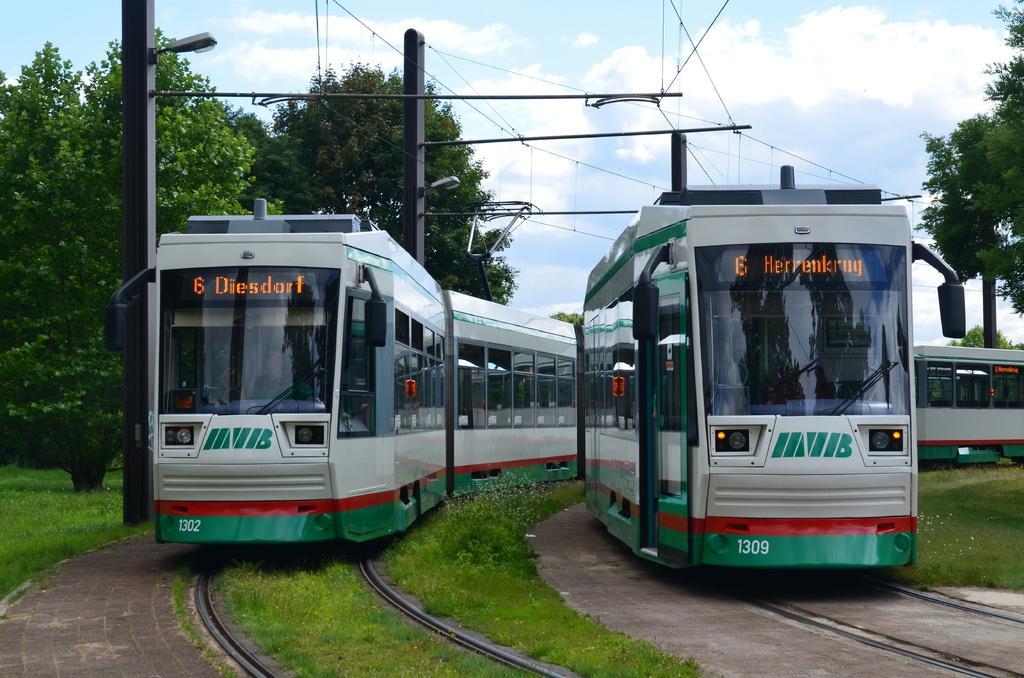Describe this image in one or two sentences. In this picture we can see two trains on railway tracks, grass, poles, wires, trees and in the background we can see the sky with clouds. 